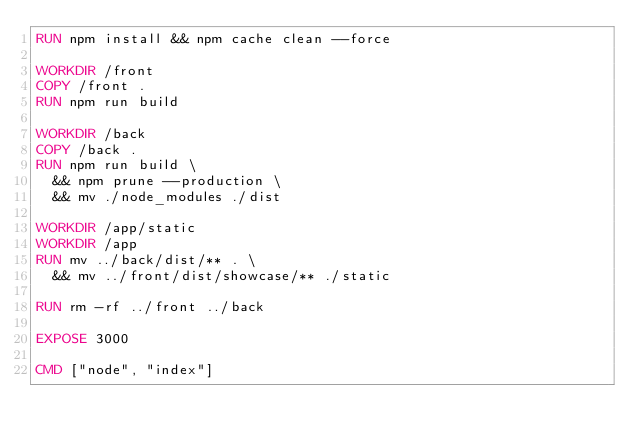<code> <loc_0><loc_0><loc_500><loc_500><_Dockerfile_>RUN npm install && npm cache clean --force

WORKDIR /front
COPY /front .
RUN npm run build

WORKDIR /back
COPY /back .
RUN npm run build \
  && npm prune --production \
  && mv ./node_modules ./dist

WORKDIR /app/static
WORKDIR /app
RUN mv ../back/dist/** . \
  && mv ../front/dist/showcase/** ./static

RUN rm -rf ../front ../back

EXPOSE 3000

CMD ["node", "index"]
</code> 